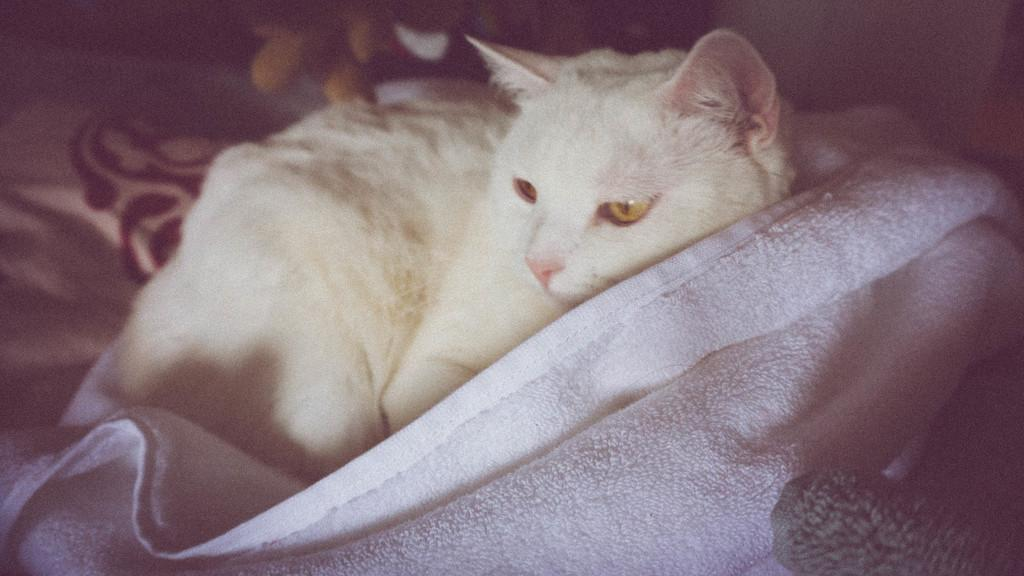What type of animal is in the image? There is a white color cat in the image. Where is the cat located in the image? The cat is lying on the bed. What else can be seen on the bed in the image? There is a blanket in the image. In which setting is the image taken? The image is taken in a room. What type of scissors can be seen cutting the lead in the image? There are no scissors or lead present in the image; it features a white color cat lying on a bed in a room. 